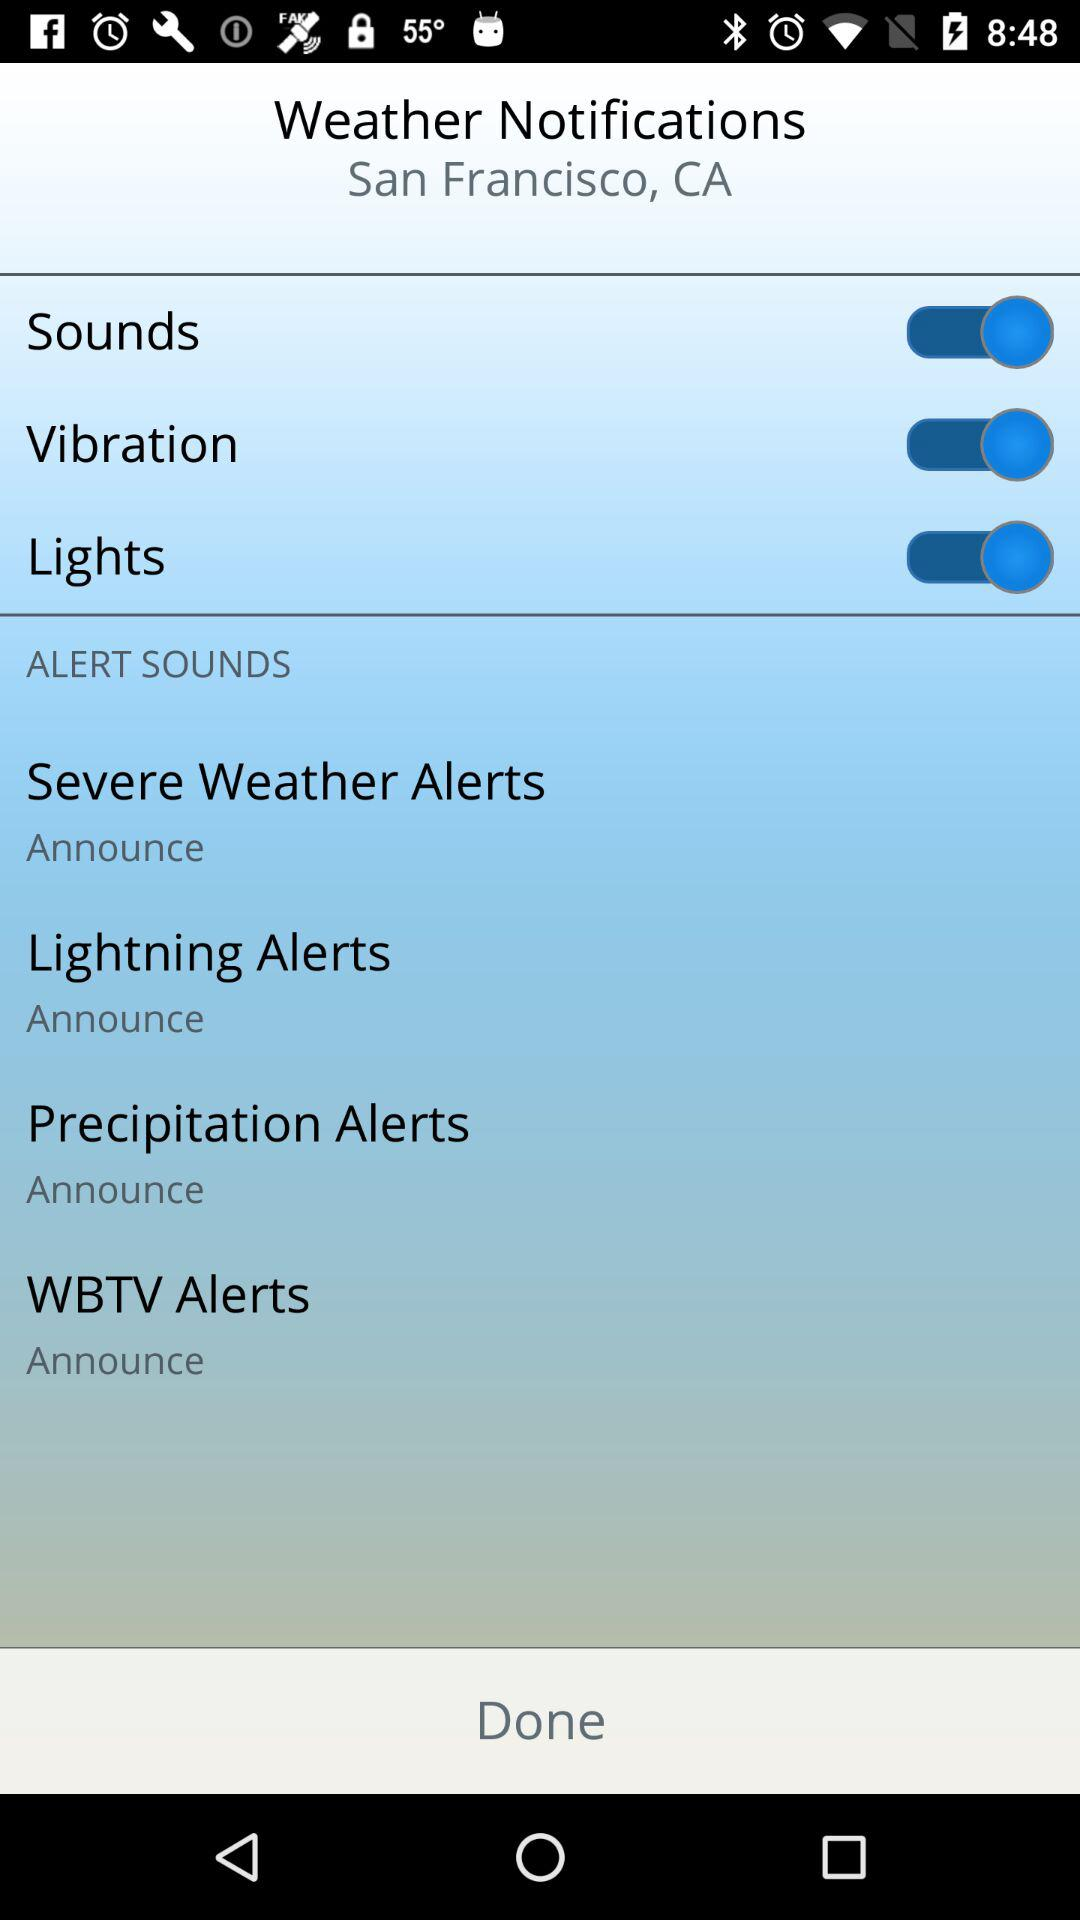What is the setting for "Severe Weather Alerts"? The setting for "Severe Weather Alerts" is "Announce". 